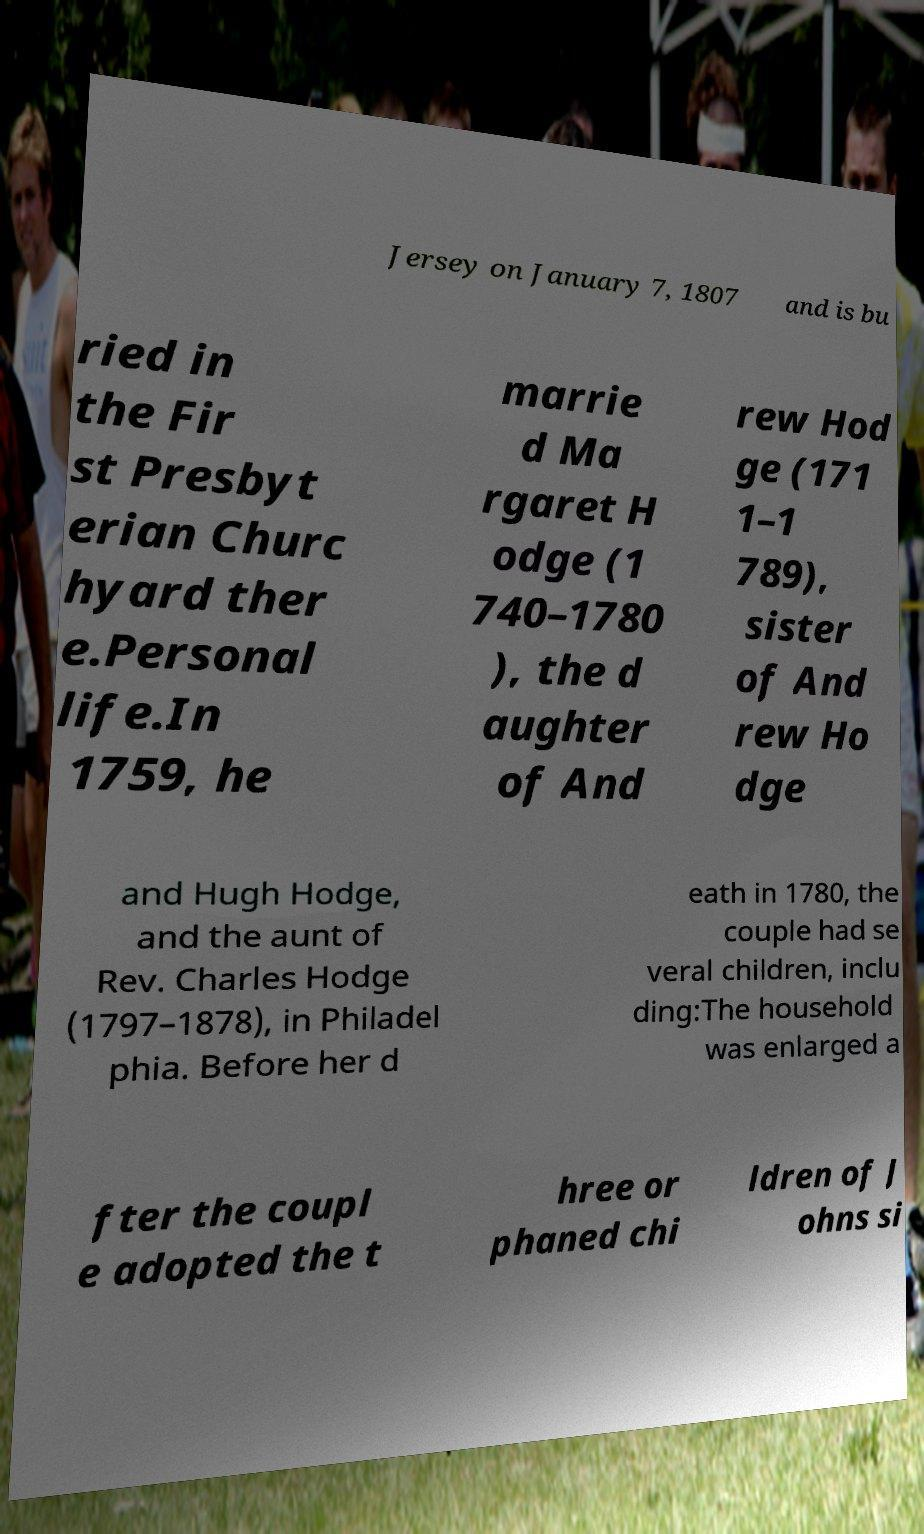I need the written content from this picture converted into text. Can you do that? Jersey on January 7, 1807 and is bu ried in the Fir st Presbyt erian Churc hyard ther e.Personal life.In 1759, he marrie d Ma rgaret H odge (1 740–1780 ), the d aughter of And rew Hod ge (171 1–1 789), sister of And rew Ho dge and Hugh Hodge, and the aunt of Rev. Charles Hodge (1797–1878), in Philadel phia. Before her d eath in 1780, the couple had se veral children, inclu ding:The household was enlarged a fter the coupl e adopted the t hree or phaned chi ldren of J ohns si 